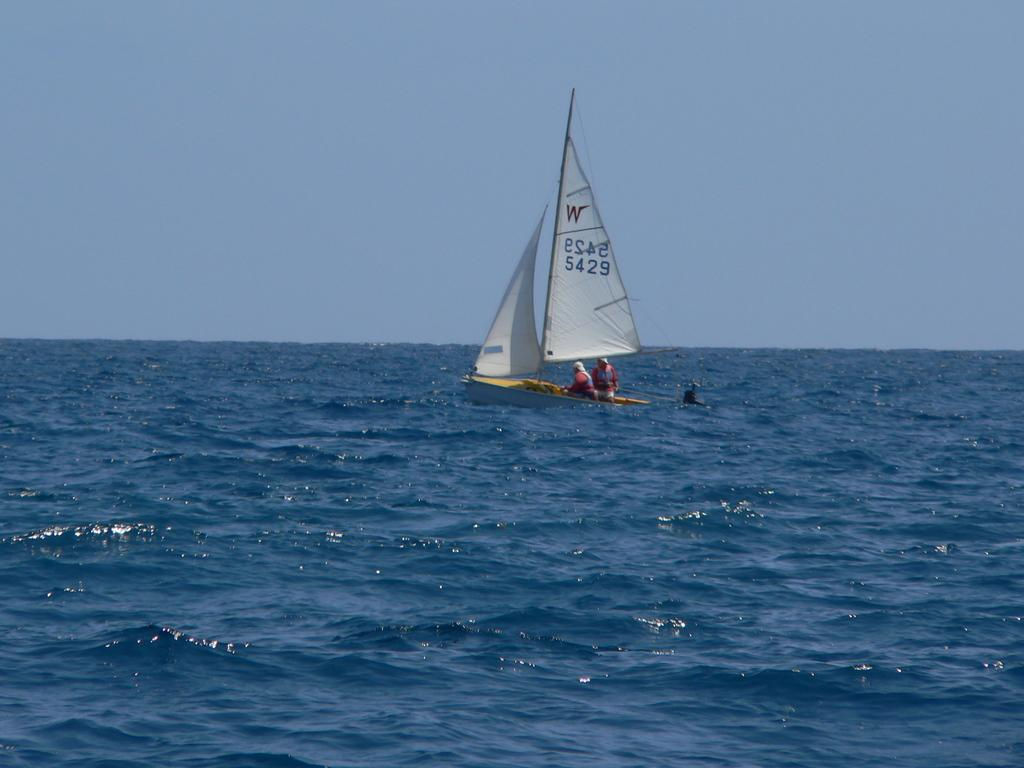How many people are in the image? There are two people in the image. What are the people doing in the image? The people are on a boat. Where is the boat located in the image? The boat is on water. What can be seen in the background of the image? The sky is visible in the background of the image. Where is the rake stored in the image? There is no rake present in the image. What type of addition is being made to the boat in the image? There is no addition being made to the boat in the image. 